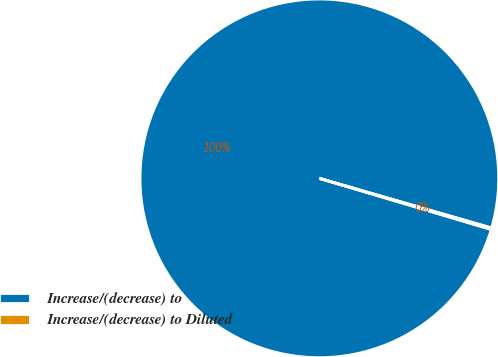Convert chart to OTSL. <chart><loc_0><loc_0><loc_500><loc_500><pie_chart><fcel>Increase/(decrease) to<fcel>Increase/(decrease) to Diluted<nl><fcel>99.86%<fcel>0.14%<nl></chart> 